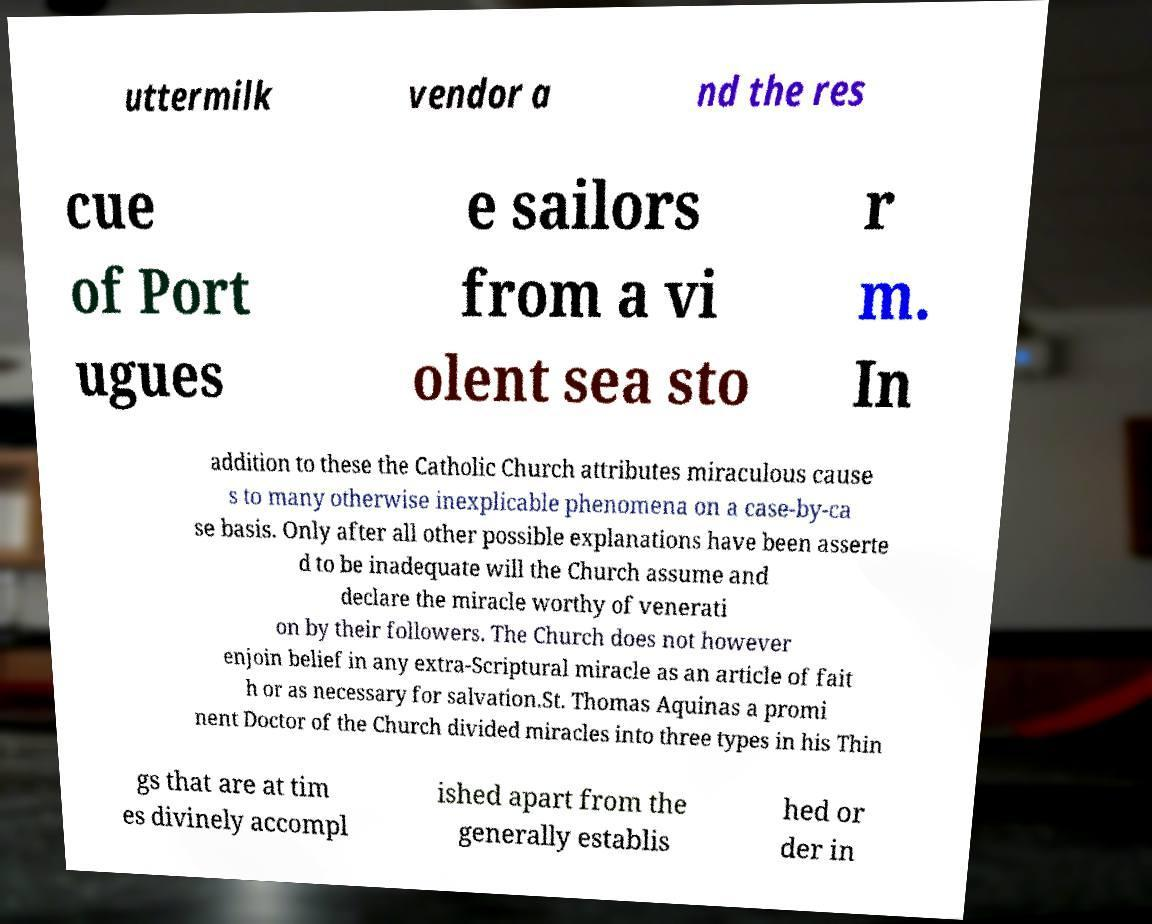For documentation purposes, I need the text within this image transcribed. Could you provide that? uttermilk vendor a nd the res cue of Port ugues e sailors from a vi olent sea sto r m. In addition to these the Catholic Church attributes miraculous cause s to many otherwise inexplicable phenomena on a case-by-ca se basis. Only after all other possible explanations have been asserte d to be inadequate will the Church assume and declare the miracle worthy of venerati on by their followers. The Church does not however enjoin belief in any extra-Scriptural miracle as an article of fait h or as necessary for salvation.St. Thomas Aquinas a promi nent Doctor of the Church divided miracles into three types in his Thin gs that are at tim es divinely accompl ished apart from the generally establis hed or der in 